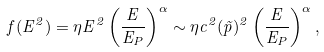Convert formula to latex. <formula><loc_0><loc_0><loc_500><loc_500>f ( E ^ { 2 } ) = \eta E ^ { 2 } \left ( \frac { E } { E _ { P } } \right ) ^ { \alpha } \sim \eta c ^ { 2 } ( { \vec { p } } ) ^ { 2 } \left ( \frac { E } { E _ { P } } \right ) ^ { \alpha } ,</formula> 